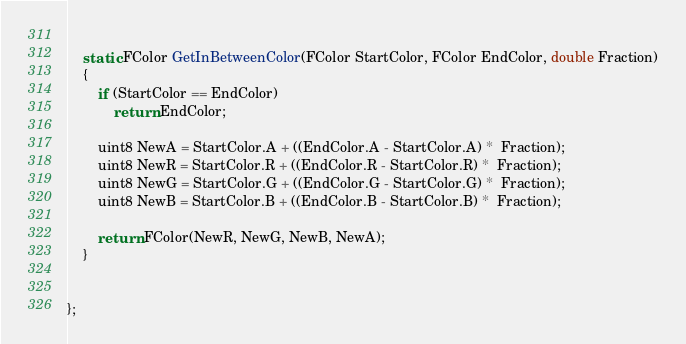<code> <loc_0><loc_0><loc_500><loc_500><_C_>	
	static FColor GetInBetweenColor(FColor StartColor, FColor EndColor, double Fraction)
	{
		if (StartColor == EndColor)
			return EndColor;

		uint8 NewA = StartColor.A + ((EndColor.A - StartColor.A) *  Fraction);
		uint8 NewR = StartColor.R + ((EndColor.R - StartColor.R) *  Fraction);
		uint8 NewG = StartColor.G + ((EndColor.G - StartColor.G) *  Fraction);
		uint8 NewB = StartColor.B + ((EndColor.B - StartColor.B) *  Fraction);
		
		return FColor(NewR, NewG, NewB, NewA);
	}


};</code> 